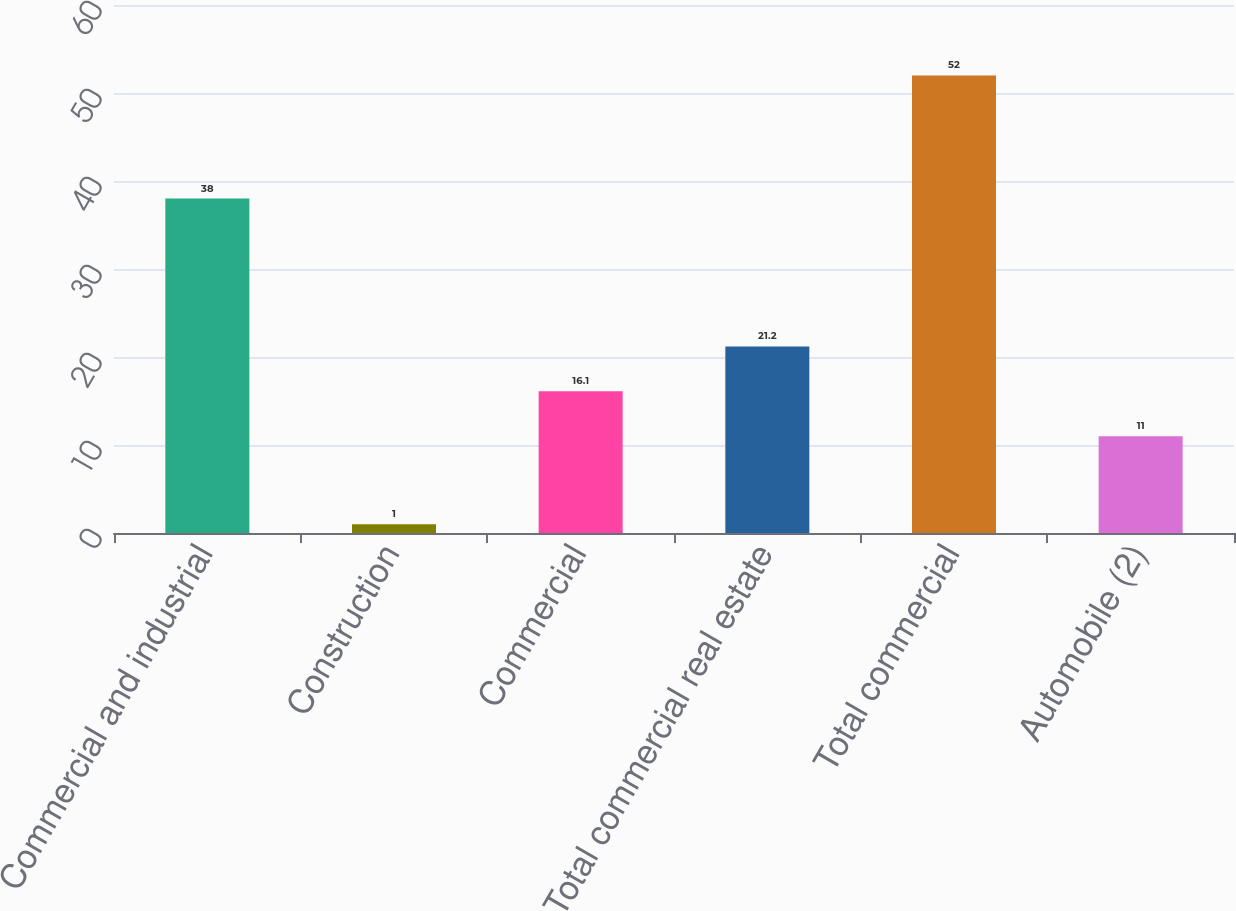Convert chart. <chart><loc_0><loc_0><loc_500><loc_500><bar_chart><fcel>Commercial and industrial<fcel>Construction<fcel>Commercial<fcel>Total commercial real estate<fcel>Total commercial<fcel>Automobile (2)<nl><fcel>38<fcel>1<fcel>16.1<fcel>21.2<fcel>52<fcel>11<nl></chart> 